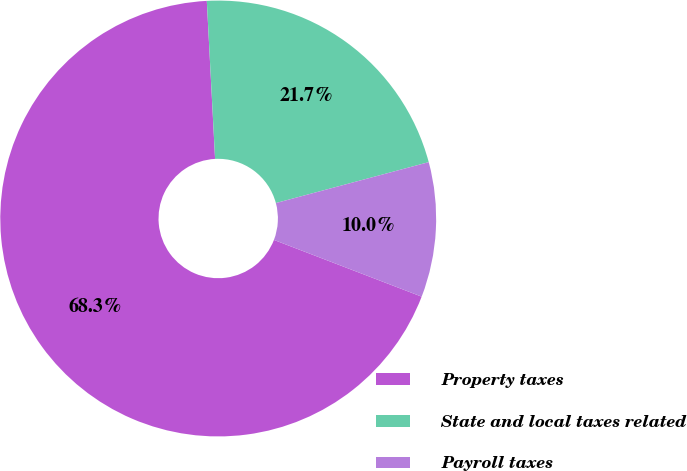Convert chart to OTSL. <chart><loc_0><loc_0><loc_500><loc_500><pie_chart><fcel>Property taxes<fcel>State and local taxes related<fcel>Payroll taxes<nl><fcel>68.33%<fcel>21.67%<fcel>10.0%<nl></chart> 